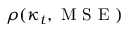Convert formula to latex. <formula><loc_0><loc_0><loc_500><loc_500>\rho ( \kappa _ { t } , M S E )</formula> 